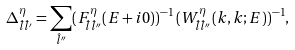<formula> <loc_0><loc_0><loc_500><loc_500>\Delta ^ { \eta } _ { \hat { l } \hat { l } ^ { \prime } } = \sum _ { \hat { l } ^ { \prime \prime } } ( F ^ { \eta } _ { \hat { l } \hat { l } ^ { \prime \prime } } ( E + i 0 ) ) ^ { - 1 } \, ( W ^ { \eta } _ { \hat { l } \hat { l } ^ { \prime \prime } } ( k , k ; E ) ) ^ { - 1 } ,</formula> 